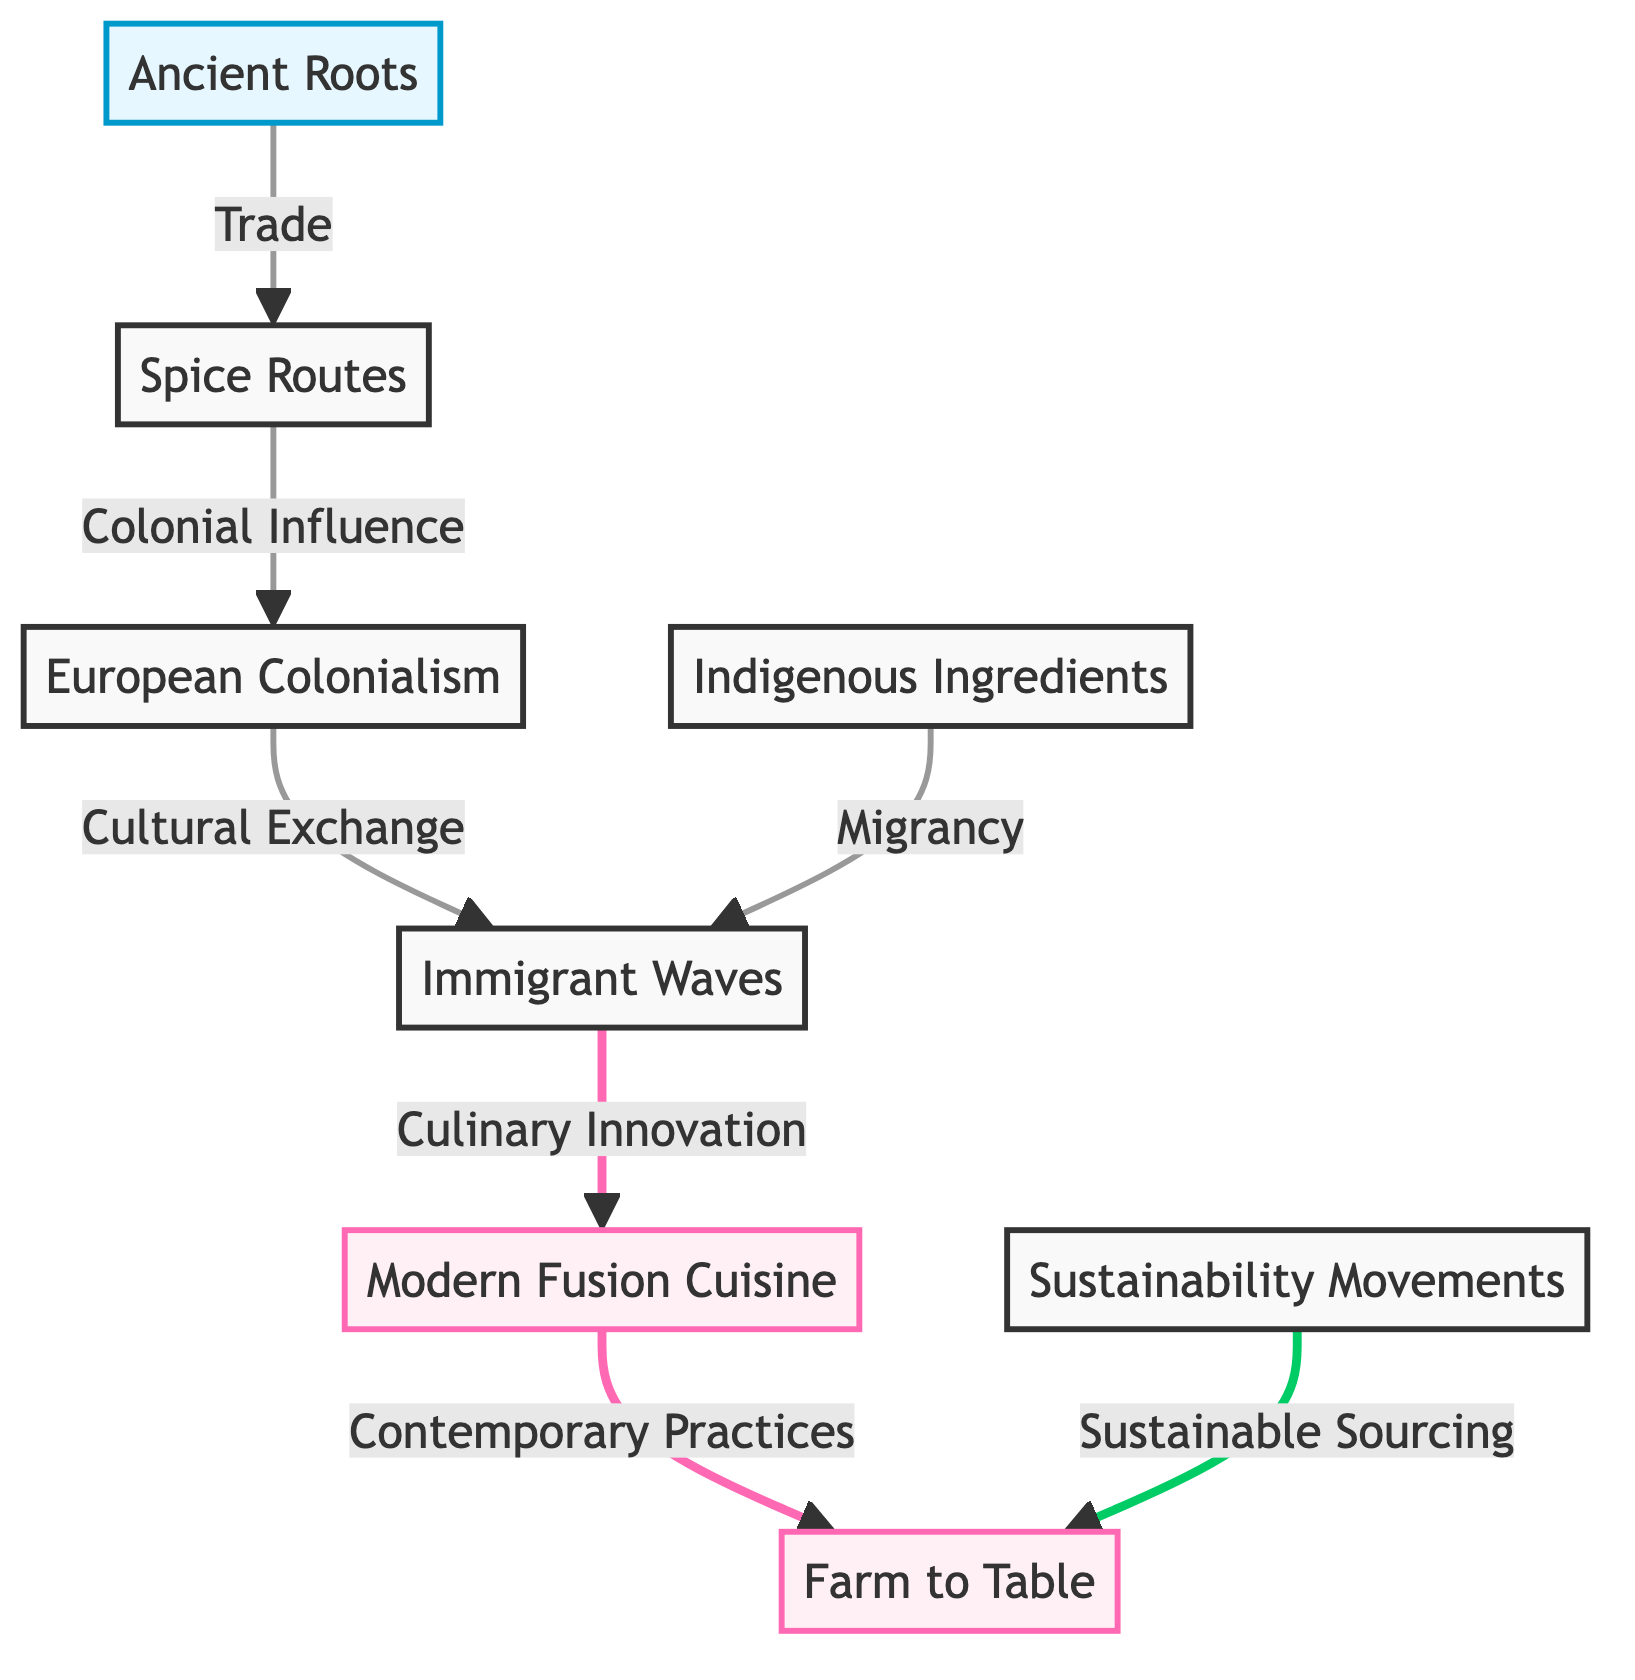What are the ancient influences depicted in this food chain? The food chain includes a node labeled "Ancient Roots," which signifies the foundational influences on culinary traditions. This node connects to other elements through trade, indicating its primary role as the origin.
Answer: Ancient Roots How many nodes are there in the diagram? Counting all the distinct nodes in the flowchart, we find a total of eight nodes representing various influences on modern food chains.
Answer: 8 What influence connects spice routes to European colonialism? The node "Spice Routes" leads to "European Colonialism" through the relationship labeled "Colonial Influence," revealing the impact of trade routes on colonial practices.
Answer: Colonial Influence Which node is influenced by both migrant waves and indigenous ingredients? Both "Indigenous Ingredients" and "Immigrant Waves" lead to "Culinary Innovation," illustrating the dynamic exchange of cooking practices and flavors that result from these influences.
Answer: Culinary Innovation What does modern fusion cuisine derive from? The node "Modern Fusion Cuisine" arises from the influence of "Culinary Innovation," showing the evolution of culinary practices that blend various traditions from both indigenous and immigrant influences.
Answer: Culinary Innovation What sustainable practice connects contemporary cuisine to modern values? "Modern Fusion Cuisine" links to "Farm to Table" through "Contemporary Practices," highlighting a modern approach to sourcing ingredients sustainably.
Answer: Contemporary Practices Which factor leads to the interplay between sustainability movements and modern culinary practices? The node "Sustainability Movements" feeds into "Farm to Table," indicating that sustainable sourcing is integrated into contemporary food chains through these movements.
Answer: Sustainability Movements What role do immigrant waves play in culinary innovation? The flow from "Immigrant Waves" to "Culinary Innovation" signifies that waves of immigrants contribute significantly to culinary creativity by introducing new ingredients and techniques.
Answer: Culinary Innovation 